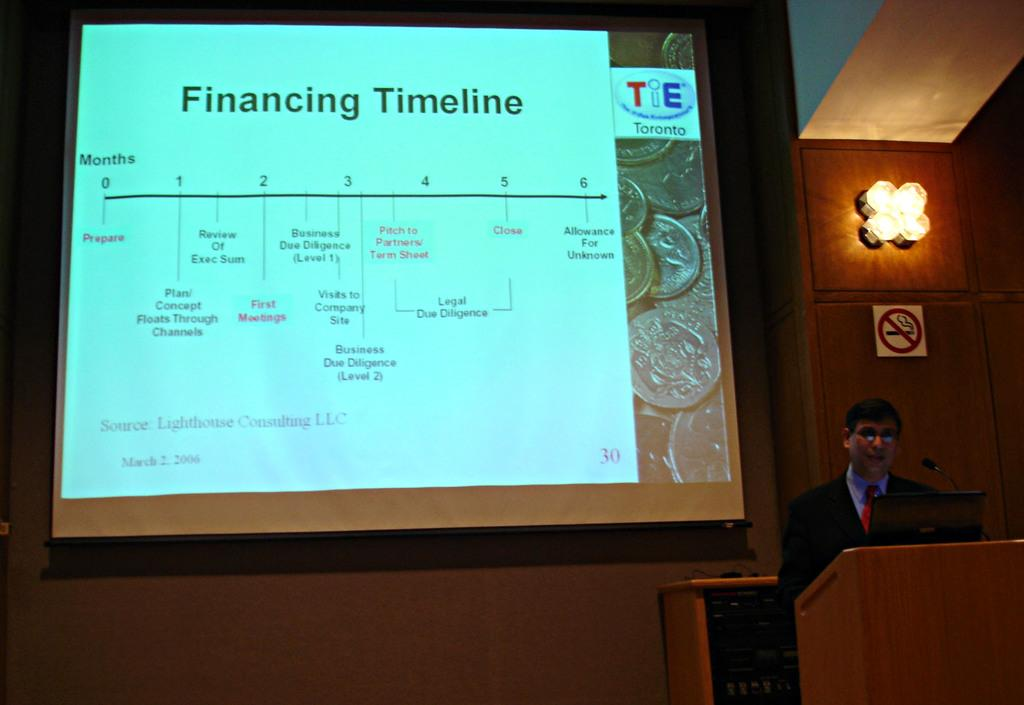What is displayed at the top of the image? There is a projector display at the top of the image. What is located at the bottom of the image? There is a cupboard at the bottom of the image. What can be seen near the center of the image? A person is standing near a podium in the image. What is used for displaying information in the image? There is a sign board in the image. What electronic device is present in the image? A laptop is present in the image. How many appliances are visible in the image? There is no appliance present in the image. What type of chair is the person sitting on in the image? There is no chair present in the image; the person is standing near a podium. 